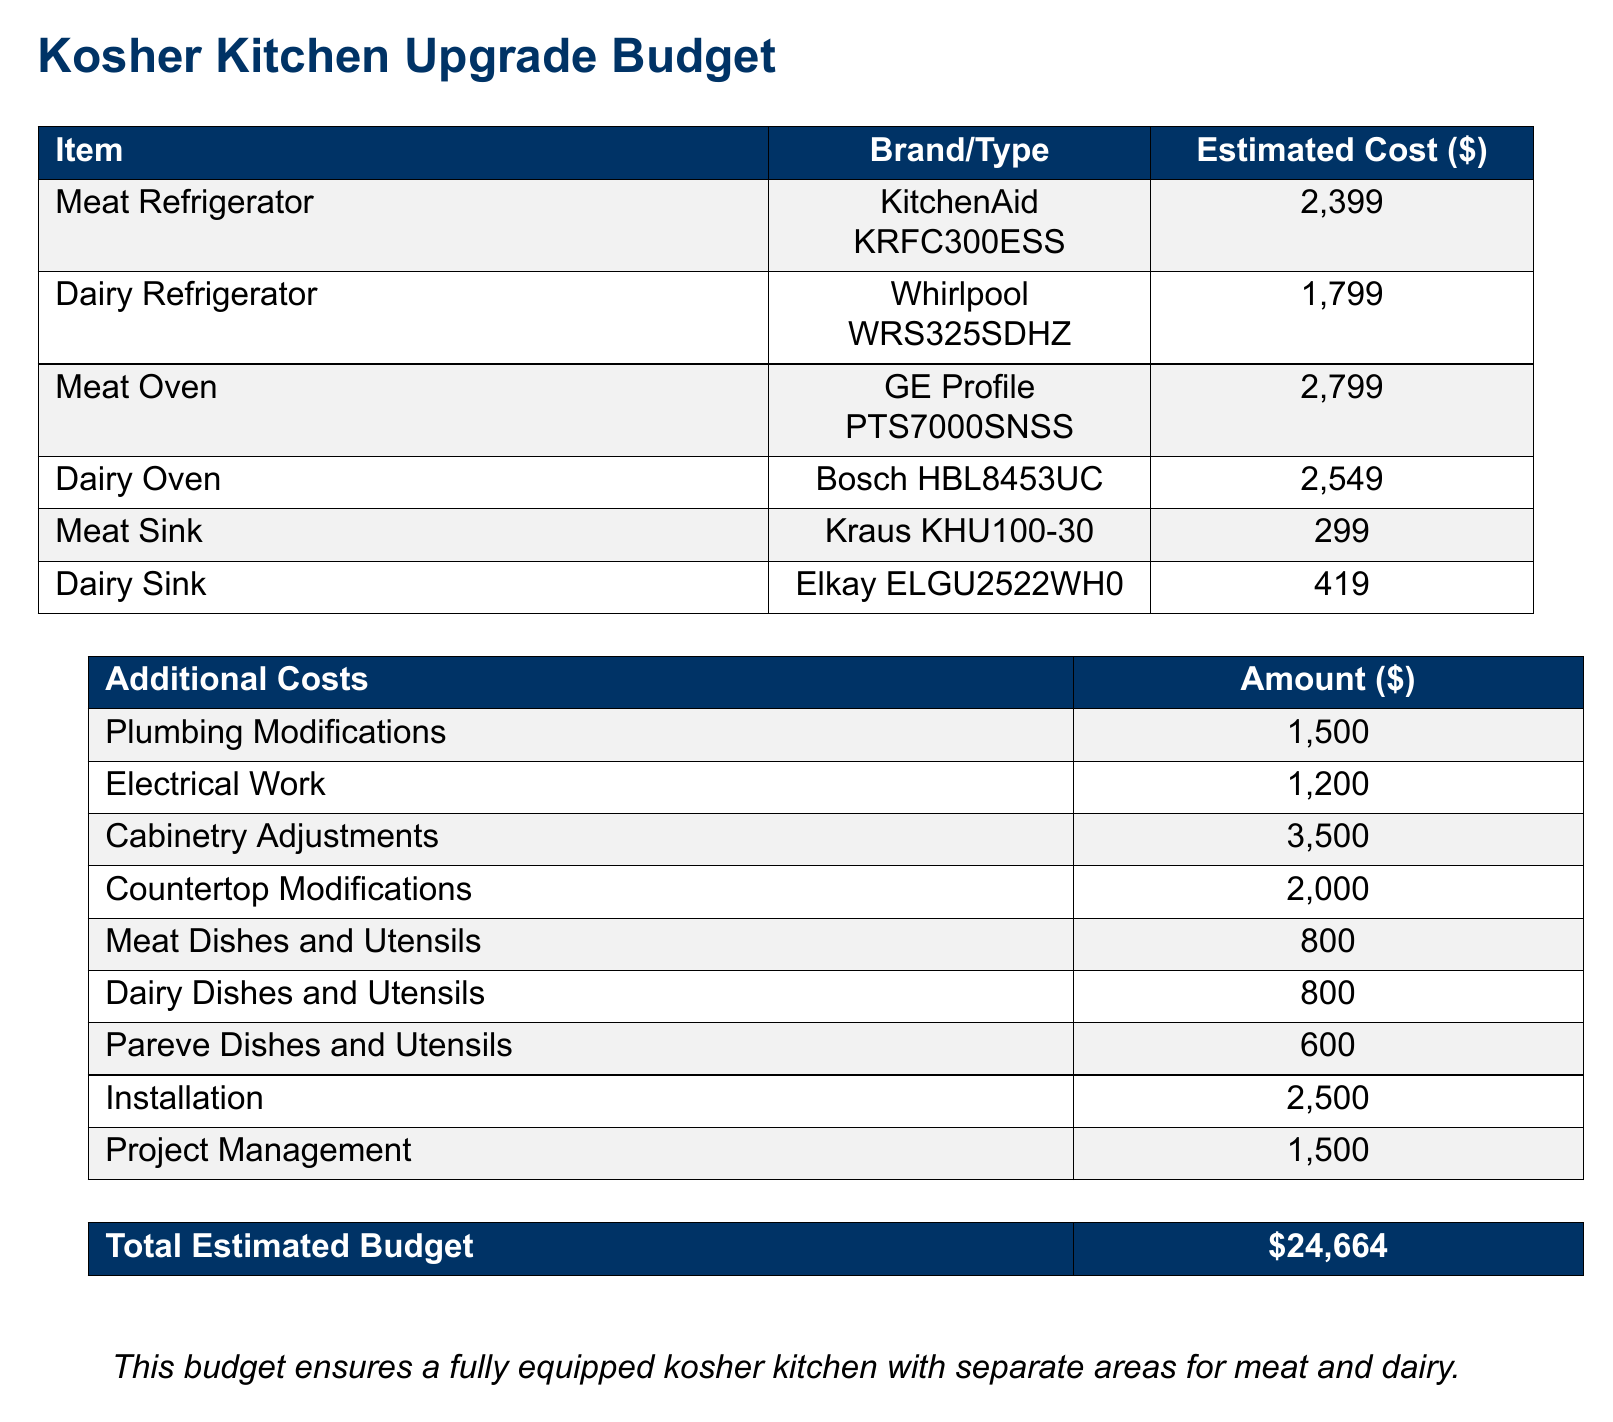What is the cost of the Meat Refrigerator? The Meat Refrigerator's cost is listed in the budget under the item "Meat Refrigerator", which is $2,399.
Answer: $2,399 How much is allocated for Plumbing Modifications? The amount allocated for Plumbing Modifications is found in the Additional Costs section, which specifies $1,500.
Answer: $1,500 What brand is listed for the Dairy Sink? The Dairy Sink brand can be identified in the budget table where it's specified as "Elkay" for the item "Dairy Sink."
Answer: Elkay What is the estimated cost for Installation? The estimated cost for Installation can be retrieved from the Additional Costs section, which indicates $2,500.
Answer: $2,500 What is the total estimated budget for the kitchen upgrade? The total estimated budget is summarized at the end of the document, which totals $24,664.
Answer: $24,664 Which item has the highest cost in the budget? By comparing the estimated costs listed, "Meat Oven" has the highest cost of $2,799.
Answer: Meat Oven How many types of dishes and utensils are accounted for in the budget? The budget accounts for three types of dishes and utensils: Meat, Dairy, and Pareve, making a total of three categories.
Answer: Three What color is used for the header in the document? The header color is defined at the beginning of the document as a specific RGB value, indicating a deep blue shade.
Answer: Deep blue 